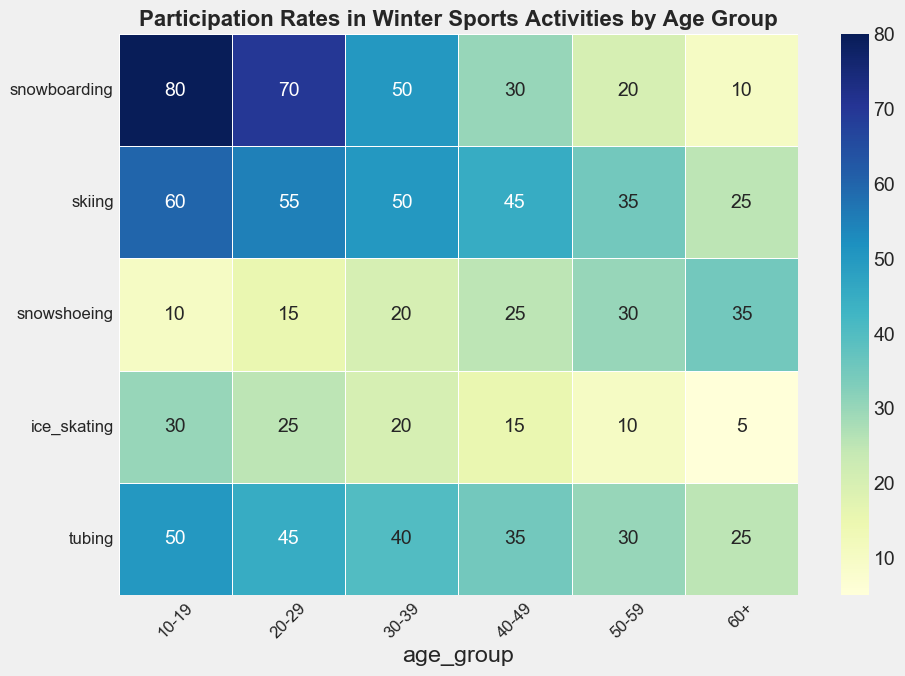What's the most popular winter sport among 10-19-year-olds? The 10-19 age group has the highest participation rate in snowboarding compared to other sports. The value for snowboarding is 80, which is the highest among the activities listed for this age group.
Answer: Snowboarding Which age group has the highest participation rate in snowshoeing? The participation rates for snowshoeing can be seen across all age groups. The 60+ age group has the highest value at 35, which is higher compared to other age groups.
Answer: 60+ Is snowboarding or skiing more popular among the 30-39 age group? The participation rate for snowboarding among the 30-39 age group is 50, while for skiing it is also 50. This shows that both sports have equal participation rates in this age group.
Answer: Equal Which two age groups have the same participation rate in ice skating? Looking at the ice skating participation rates, the 30-39 and 40-49 age groups both have a value of 20. Therefore, these two age groups have the same participation rate in ice skating.
Answer: 30-39 and 40-49 What is the total participation rate for the 20-29 age group across all activities? To find the total participation rate for the 20-29 age group, we add the participation rates for all activities: 70 (snowboarding) + 55 (skiing) + 15 (snowshoeing) + 25 (ice skating) + 45 (tubing) = 210.
Answer: 210 How does the participation rate in tubing for the 50-59 age group compare to that for the 60+ age group? The participation rate for tubing in the 50-59 age group is 30, while in the 60+ age group it is 25. The rate is higher for the 50-59 age group compared to the 60+ age group.
Answer: 50-59 is higher What is the average participation rate in ice skating across all age groups? To calculate the average participation rate in ice skating across all age groups, sum the rates: 30+25+20+15+10+5 = 105. Divide by the number of age groups (6): 105 / 6 = 17.5.
Answer: 17.5 Which age group has the lowest participation rate in snowboarding? Observing the participation rates in snowboarding across all age groups, the 60+ age group has the lowest value at 10.
Answer: 60+ Which has more participation in the 40-49 age group: snowboarding or snowshoeing? In the 40-49 age group, the participation rate for snowboarding is 30 while for snowshoeing it is 25. Therefore, snowboarding has more participation than snowshoeing in this age group.
Answer: Snowboarding What is the difference in skiing participation rates between the 20-29 and 50-59 age groups? The skiing participation rate for the 20-29 age group is 55 and for the 50-59 age group it is 35. The difference between them is 55 - 35 = 20.
Answer: 20 